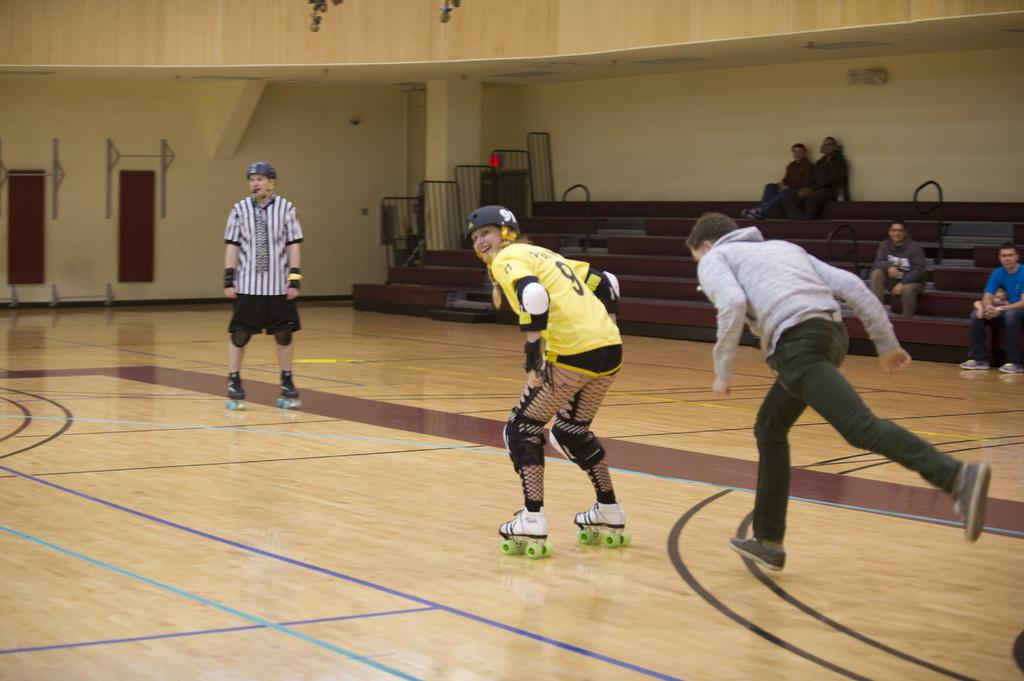How many people are in the image? There are people in the image, but the exact number is not specified. What are some of the people doing in the image? Some people are sitting, and some are skating on the floor. What can be seen on the wall in the image? There is a grille and boards on the wall. What type of sky is visible through the net in the image? There is no net or sky visible in the image. 